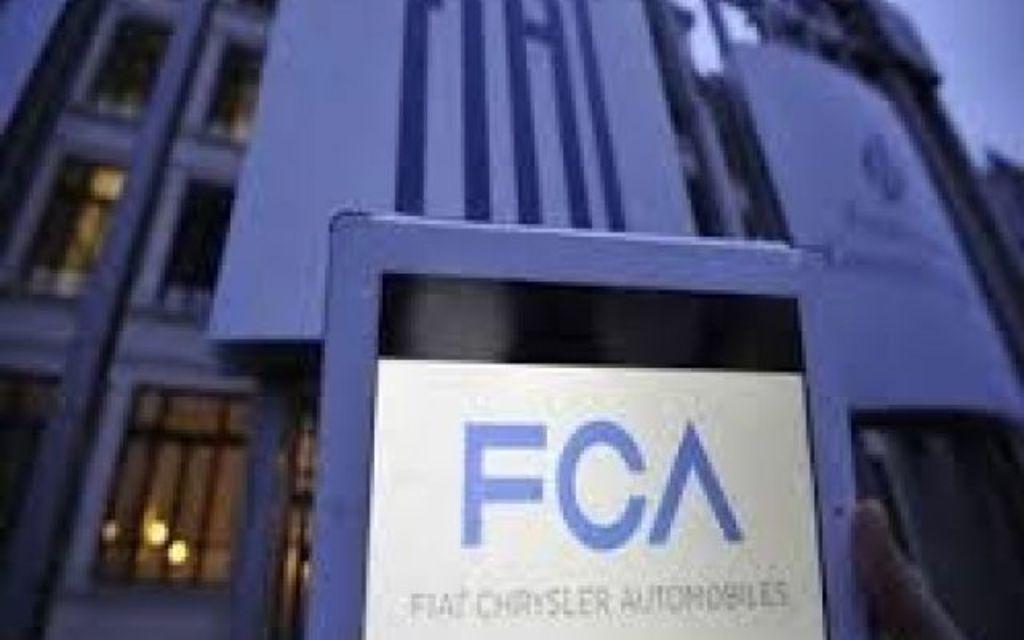Describe this image in one or two sentences. Here I can see a blue color board on which a paper is attached. On this paper I can see some text. In the background there is a building. 